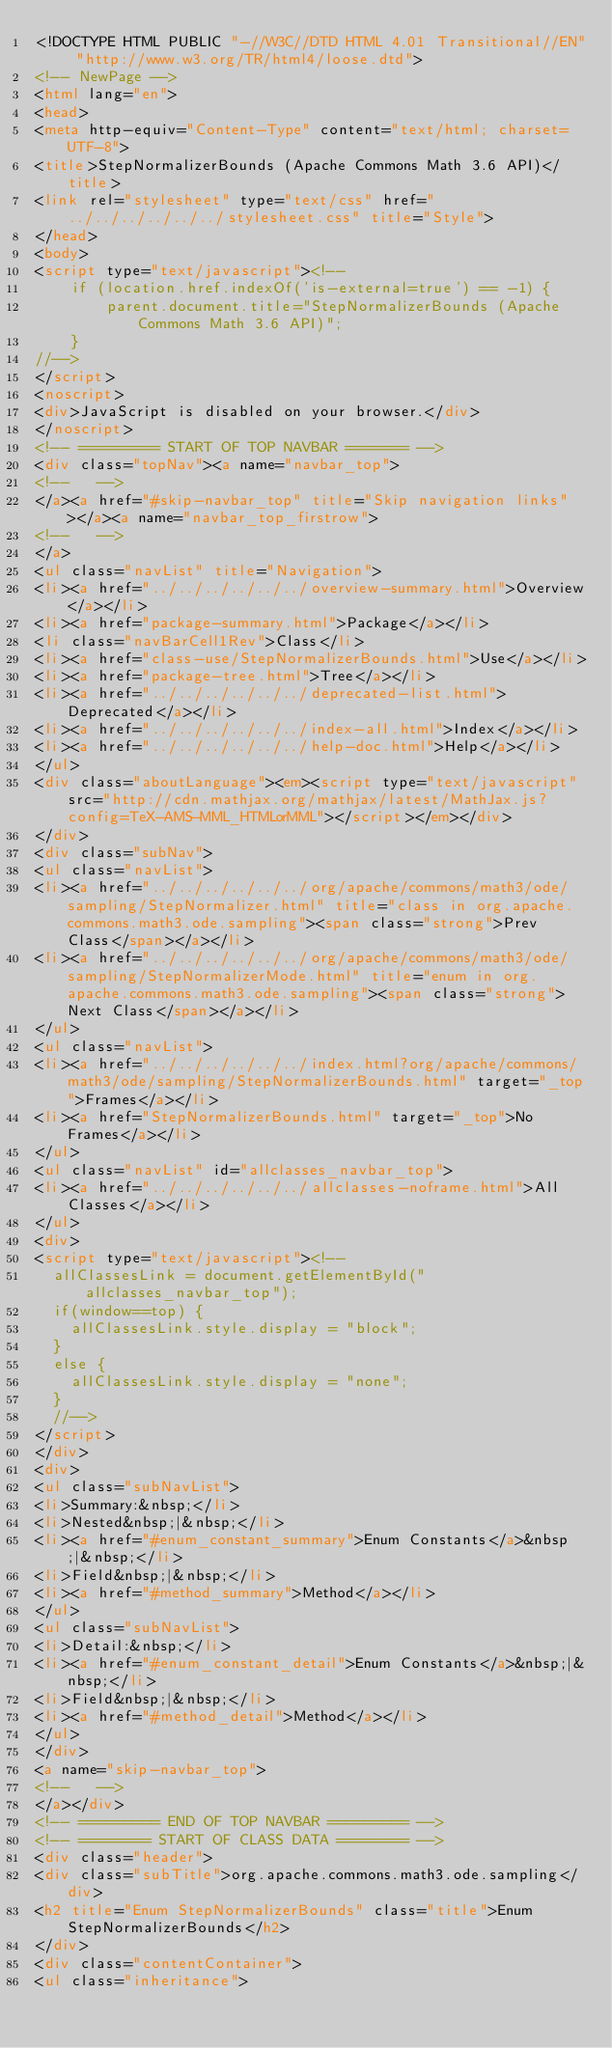Convert code to text. <code><loc_0><loc_0><loc_500><loc_500><_HTML_><!DOCTYPE HTML PUBLIC "-//W3C//DTD HTML 4.01 Transitional//EN" "http://www.w3.org/TR/html4/loose.dtd">
<!-- NewPage -->
<html lang="en">
<head>
<meta http-equiv="Content-Type" content="text/html; charset=UTF-8">
<title>StepNormalizerBounds (Apache Commons Math 3.6 API)</title>
<link rel="stylesheet" type="text/css" href="../../../../../../stylesheet.css" title="Style">
</head>
<body>
<script type="text/javascript"><!--
    if (location.href.indexOf('is-external=true') == -1) {
        parent.document.title="StepNormalizerBounds (Apache Commons Math 3.6 API)";
    }
//-->
</script>
<noscript>
<div>JavaScript is disabled on your browser.</div>
</noscript>
<!-- ========= START OF TOP NAVBAR ======= -->
<div class="topNav"><a name="navbar_top">
<!--   -->
</a><a href="#skip-navbar_top" title="Skip navigation links"></a><a name="navbar_top_firstrow">
<!--   -->
</a>
<ul class="navList" title="Navigation">
<li><a href="../../../../../../overview-summary.html">Overview</a></li>
<li><a href="package-summary.html">Package</a></li>
<li class="navBarCell1Rev">Class</li>
<li><a href="class-use/StepNormalizerBounds.html">Use</a></li>
<li><a href="package-tree.html">Tree</a></li>
<li><a href="../../../../../../deprecated-list.html">Deprecated</a></li>
<li><a href="../../../../../../index-all.html">Index</a></li>
<li><a href="../../../../../../help-doc.html">Help</a></li>
</ul>
<div class="aboutLanguage"><em><script type="text/javascript" src="http://cdn.mathjax.org/mathjax/latest/MathJax.js?config=TeX-AMS-MML_HTMLorMML"></script></em></div>
</div>
<div class="subNav">
<ul class="navList">
<li><a href="../../../../../../org/apache/commons/math3/ode/sampling/StepNormalizer.html" title="class in org.apache.commons.math3.ode.sampling"><span class="strong">Prev Class</span></a></li>
<li><a href="../../../../../../org/apache/commons/math3/ode/sampling/StepNormalizerMode.html" title="enum in org.apache.commons.math3.ode.sampling"><span class="strong">Next Class</span></a></li>
</ul>
<ul class="navList">
<li><a href="../../../../../../index.html?org/apache/commons/math3/ode/sampling/StepNormalizerBounds.html" target="_top">Frames</a></li>
<li><a href="StepNormalizerBounds.html" target="_top">No Frames</a></li>
</ul>
<ul class="navList" id="allclasses_navbar_top">
<li><a href="../../../../../../allclasses-noframe.html">All Classes</a></li>
</ul>
<div>
<script type="text/javascript"><!--
  allClassesLink = document.getElementById("allclasses_navbar_top");
  if(window==top) {
    allClassesLink.style.display = "block";
  }
  else {
    allClassesLink.style.display = "none";
  }
  //-->
</script>
</div>
<div>
<ul class="subNavList">
<li>Summary:&nbsp;</li>
<li>Nested&nbsp;|&nbsp;</li>
<li><a href="#enum_constant_summary">Enum Constants</a>&nbsp;|&nbsp;</li>
<li>Field&nbsp;|&nbsp;</li>
<li><a href="#method_summary">Method</a></li>
</ul>
<ul class="subNavList">
<li>Detail:&nbsp;</li>
<li><a href="#enum_constant_detail">Enum Constants</a>&nbsp;|&nbsp;</li>
<li>Field&nbsp;|&nbsp;</li>
<li><a href="#method_detail">Method</a></li>
</ul>
</div>
<a name="skip-navbar_top">
<!--   -->
</a></div>
<!-- ========= END OF TOP NAVBAR ========= -->
<!-- ======== START OF CLASS DATA ======== -->
<div class="header">
<div class="subTitle">org.apache.commons.math3.ode.sampling</div>
<h2 title="Enum StepNormalizerBounds" class="title">Enum StepNormalizerBounds</h2>
</div>
<div class="contentContainer">
<ul class="inheritance"></code> 